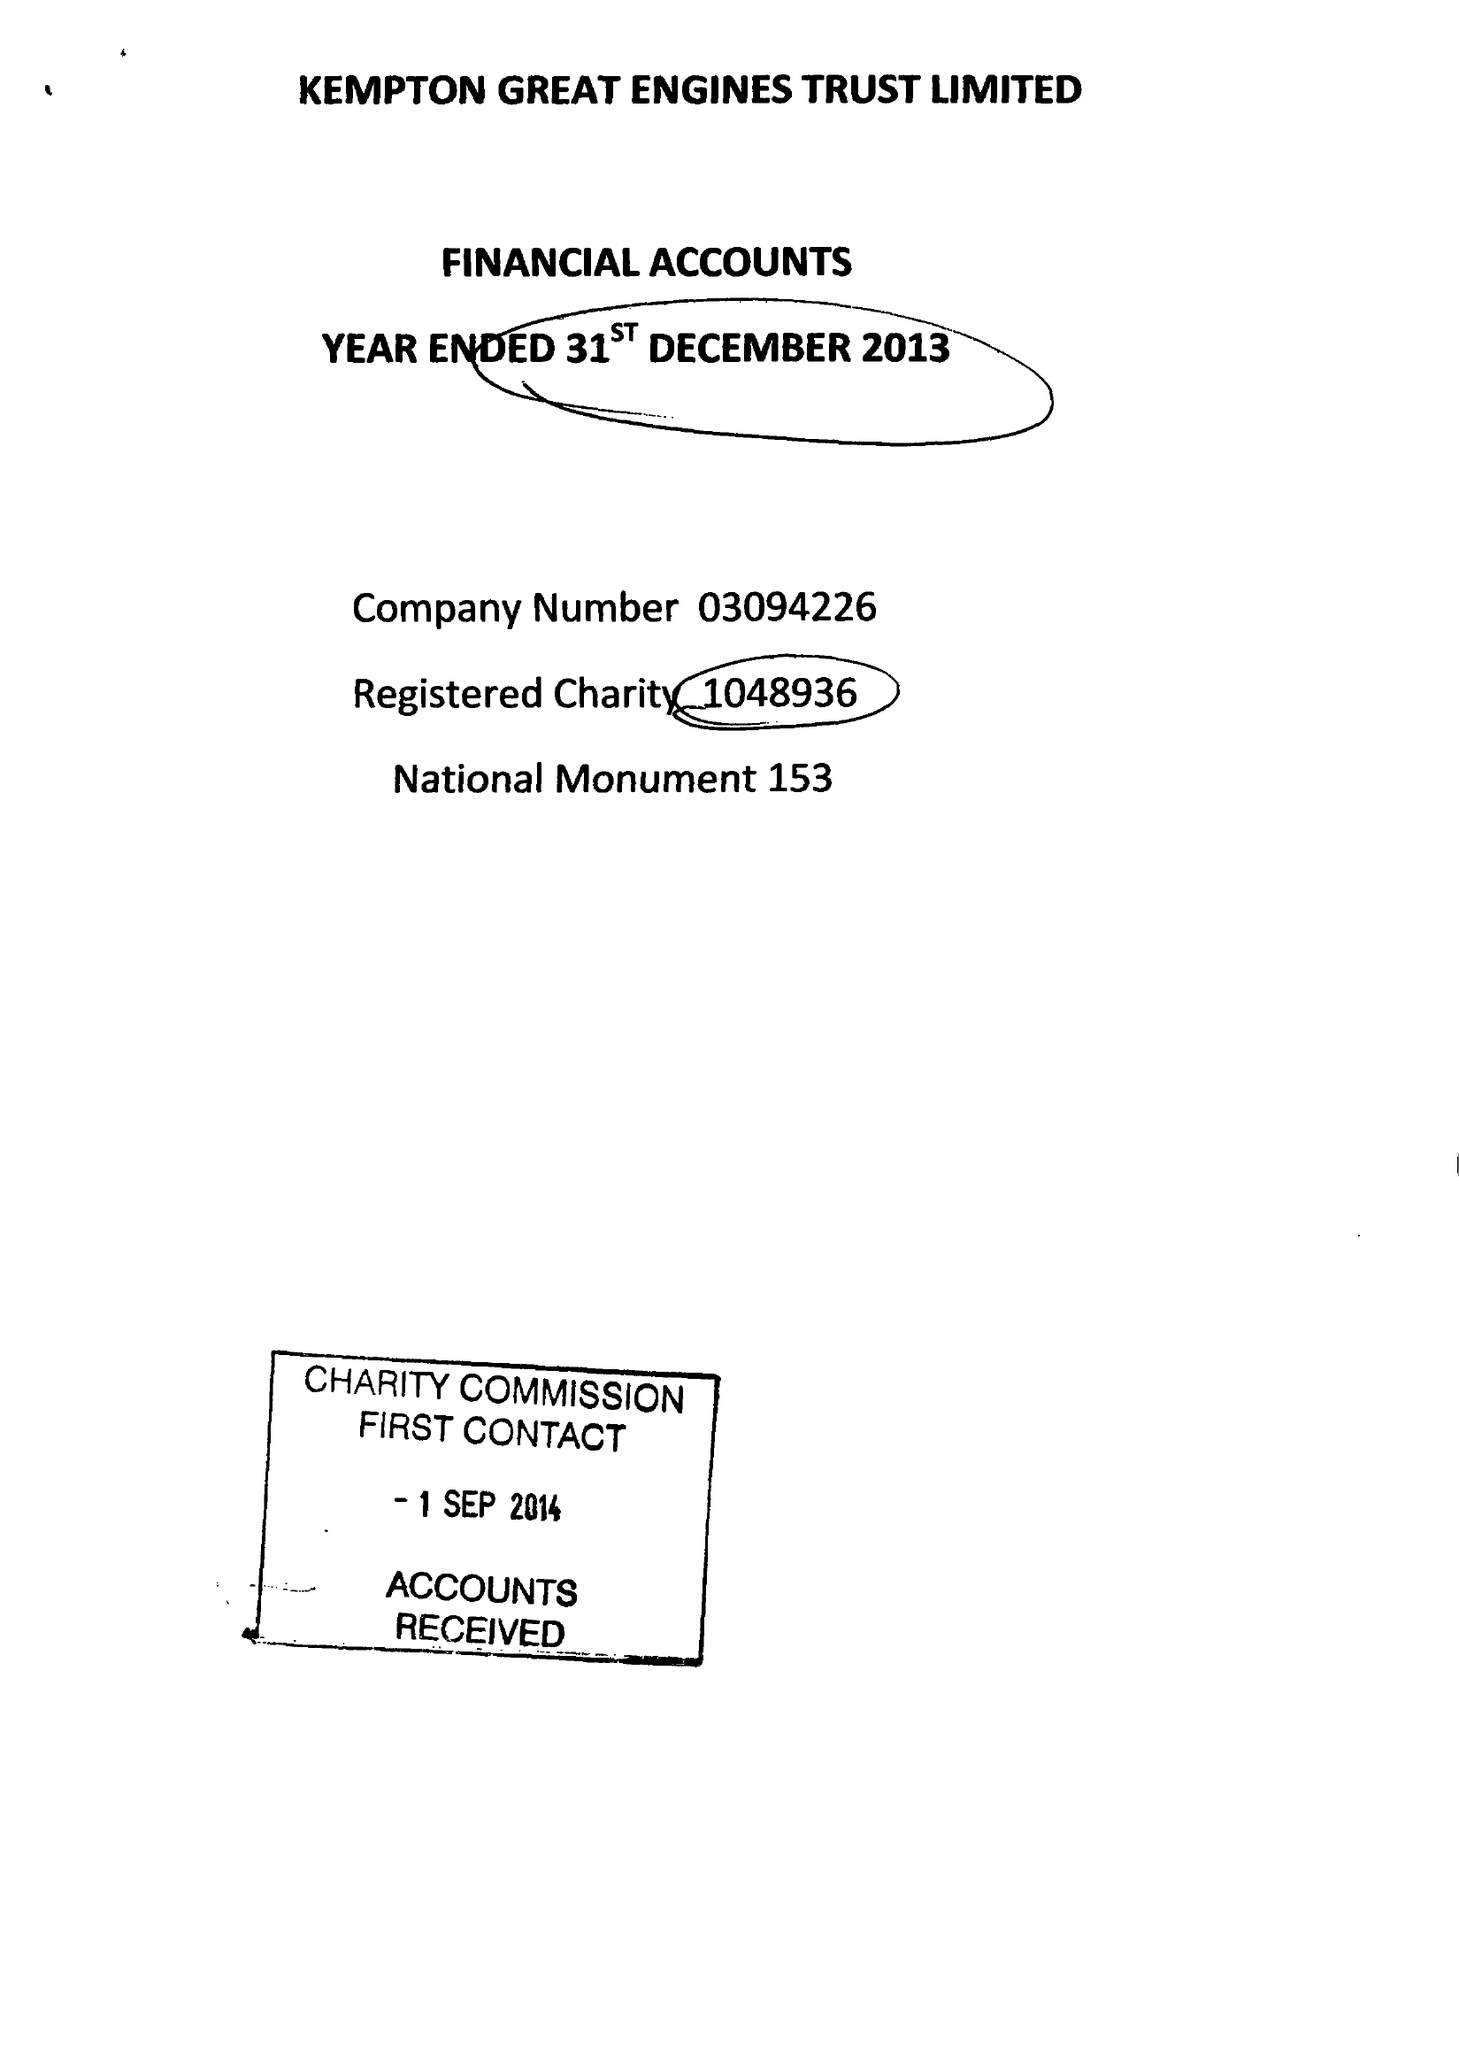What is the value for the charity_name?
Answer the question using a single word or phrase. Kempton Great Engines Trust Ltd. 